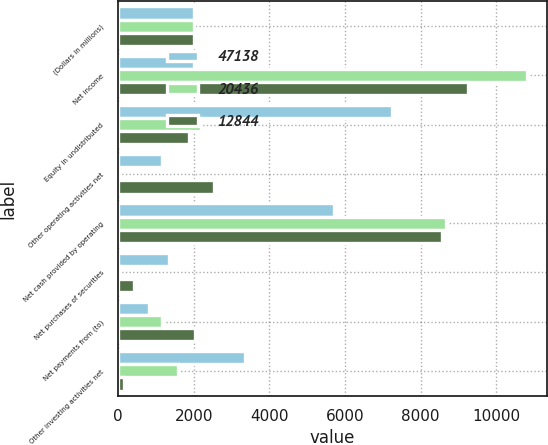<chart> <loc_0><loc_0><loc_500><loc_500><stacked_bar_chart><ecel><fcel>(Dollars in millions)<fcel>Net income<fcel>Equity in undistributed<fcel>Other operating activities net<fcel>Net cash provided by operating<fcel>Net purchases of securities<fcel>Net payments from (to)<fcel>Other investing activities net<nl><fcel>47138<fcel>2004<fcel>2003<fcel>7254<fcel>1168<fcel>5721<fcel>1348<fcel>821<fcel>3348<nl><fcel>20436<fcel>2003<fcel>10810<fcel>2187<fcel>40<fcel>8663<fcel>59<fcel>1160<fcel>1597<nl><fcel>12844<fcel>2002<fcel>9249<fcel>1867<fcel>2537<fcel>8579<fcel>428<fcel>2025<fcel>158<nl></chart> 